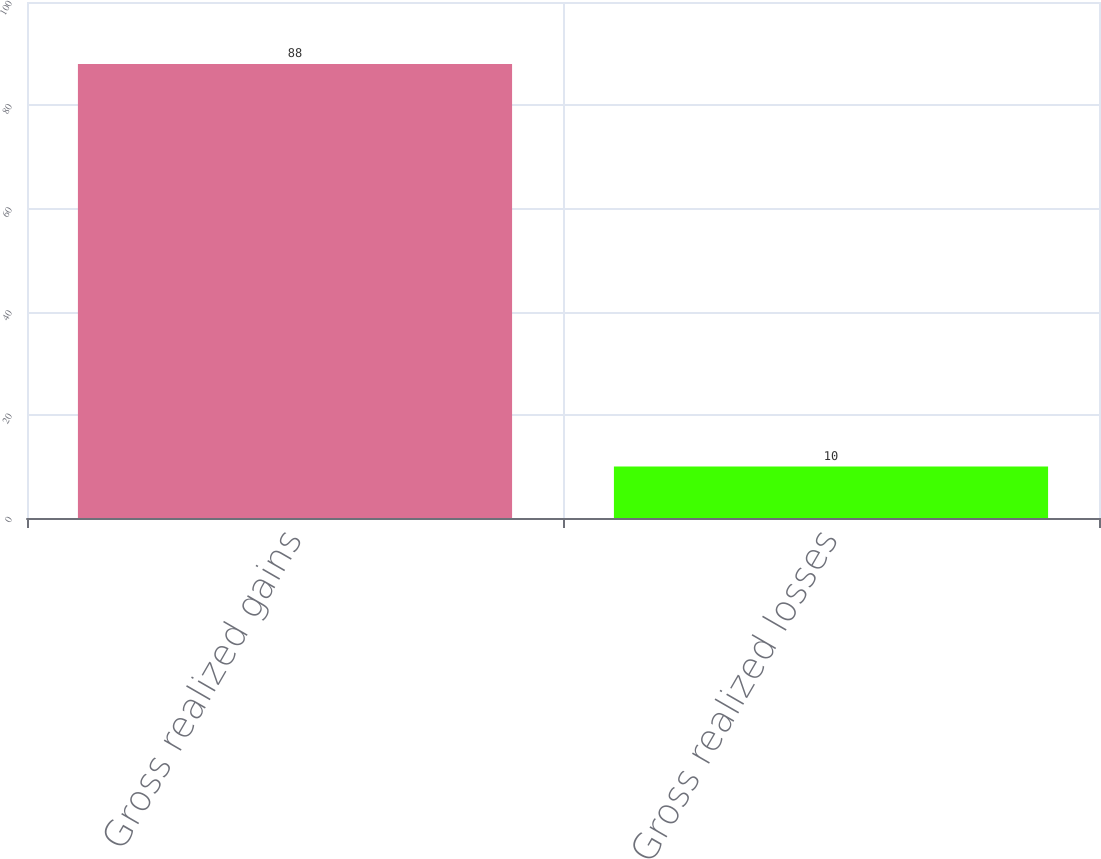Convert chart to OTSL. <chart><loc_0><loc_0><loc_500><loc_500><bar_chart><fcel>Gross realized gains<fcel>Gross realized losses<nl><fcel>88<fcel>10<nl></chart> 